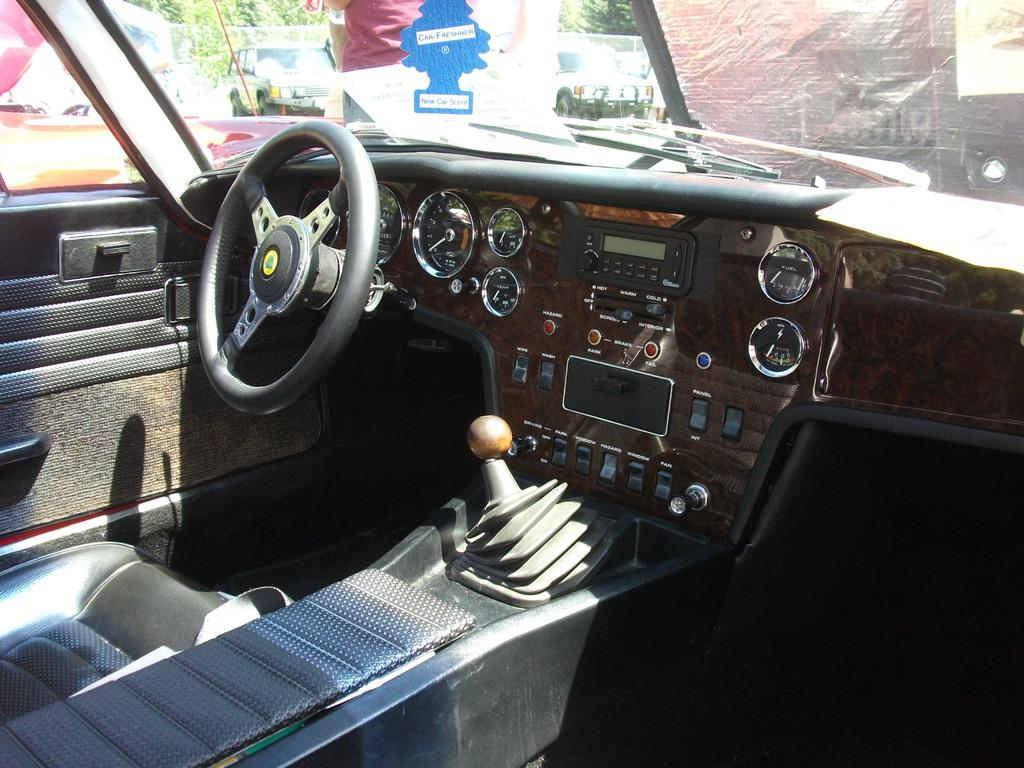What type of vehicle is shown in the image? The image shows an inner view of a car. What is used to control the direction of the car? The car has a steering wheel. What instruments are present in the car to provide information to the driver? The car has meters. How does the driver change the car's speed? The car has a gear. What can be seen outside the car through its windows? People, vehicles, and trees are visible through the car's windows. What year is the car in the image from? The provided facts do not mention the year of the car, so it cannot be determined from the image. What is the size of the car in the image? The provided facts do not mention the size of the car, so it cannot be determined from the image. 